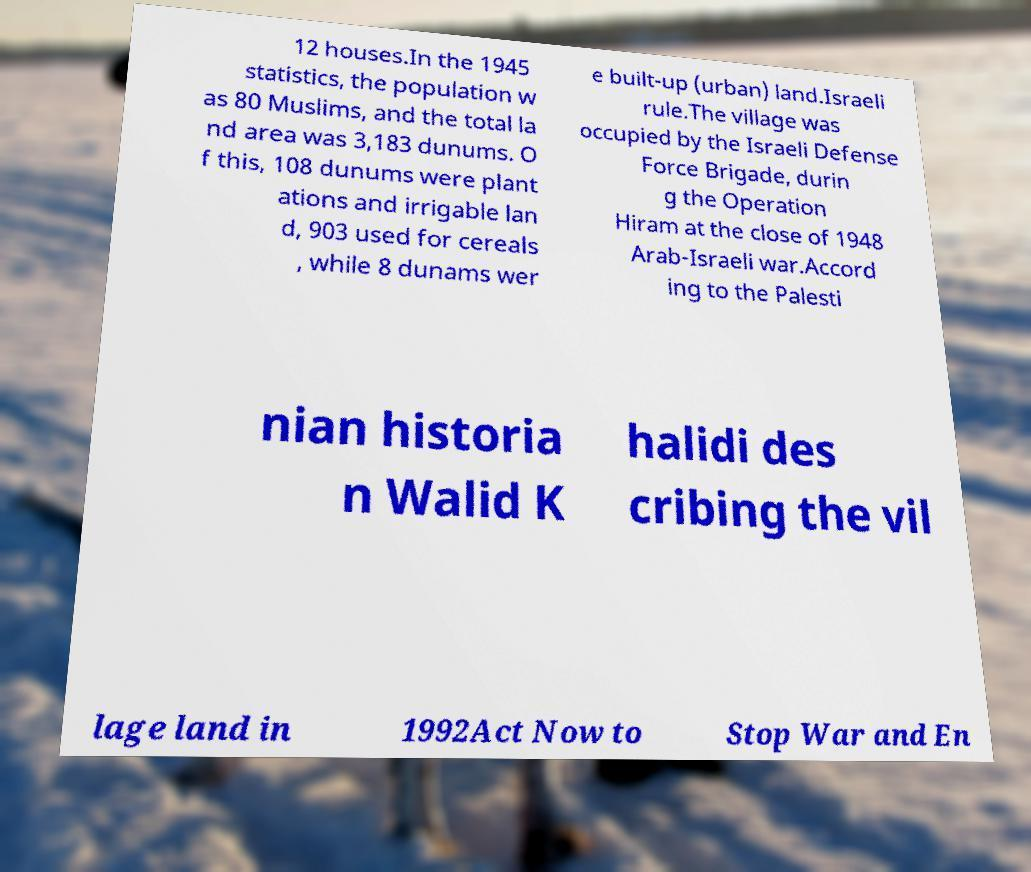Could you assist in decoding the text presented in this image and type it out clearly? 12 houses.In the 1945 statistics, the population w as 80 Muslims, and the total la nd area was 3,183 dunums. O f this, 108 dunums were plant ations and irrigable lan d, 903 used for cereals , while 8 dunams wer e built-up (urban) land.Israeli rule.The village was occupied by the Israeli Defense Force Brigade, durin g the Operation Hiram at the close of 1948 Arab-Israeli war.Accord ing to the Palesti nian historia n Walid K halidi des cribing the vil lage land in 1992Act Now to Stop War and En 